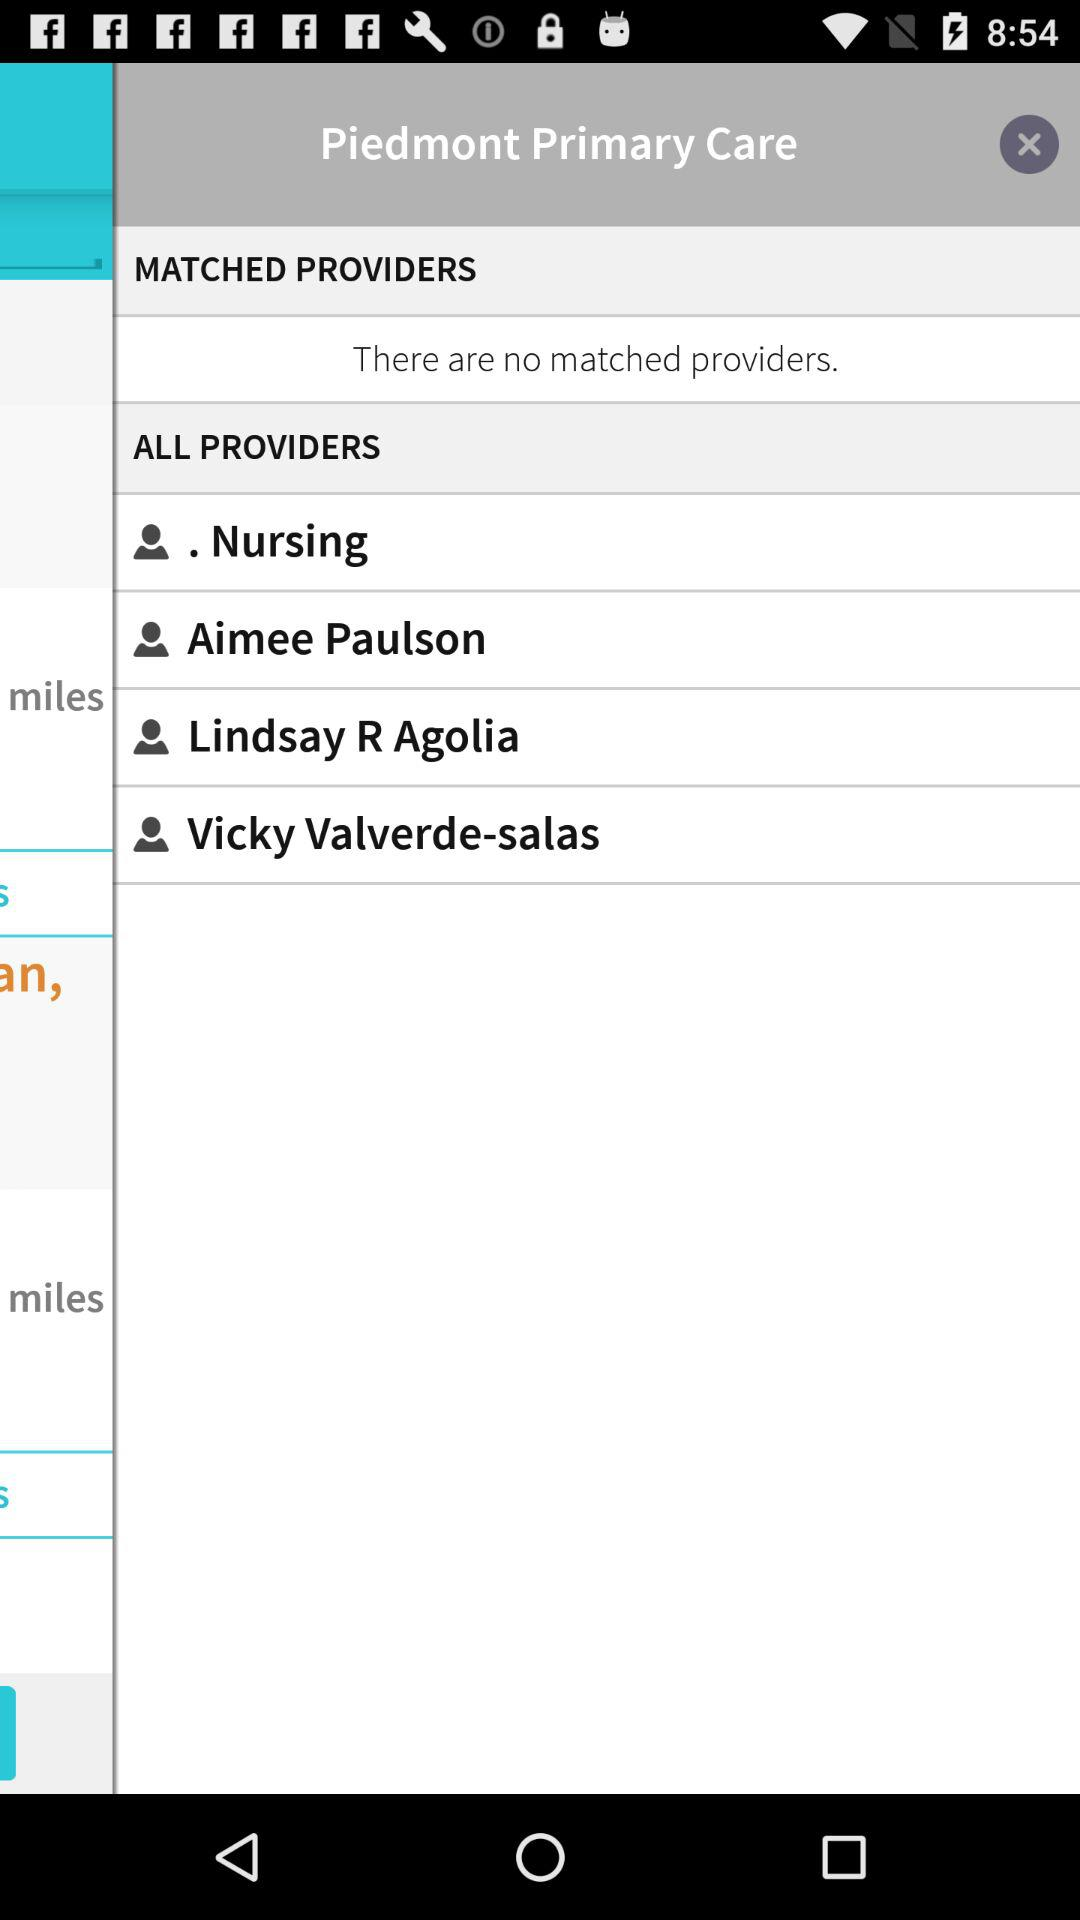How many match providers are there? There are no match providers. 